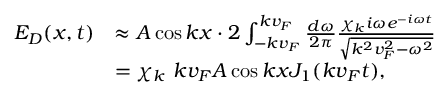<formula> <loc_0><loc_0><loc_500><loc_500>\begin{array} { r l } { E _ { D } ( x , t ) } & { \approx A \cos k x \cdot 2 \int _ { - k v _ { F } } ^ { k v _ { F } } \frac { d \omega } { 2 \pi } \frac { \chi _ { k } i \omega e ^ { - i \omega t } } { \sqrt { k ^ { 2 } v _ { F } ^ { 2 } - \omega ^ { 2 } } } } \\ & { = \chi _ { k } \ k v _ { F } A \cos k x J _ { 1 } ( k v _ { F } t ) , } \end{array}</formula> 